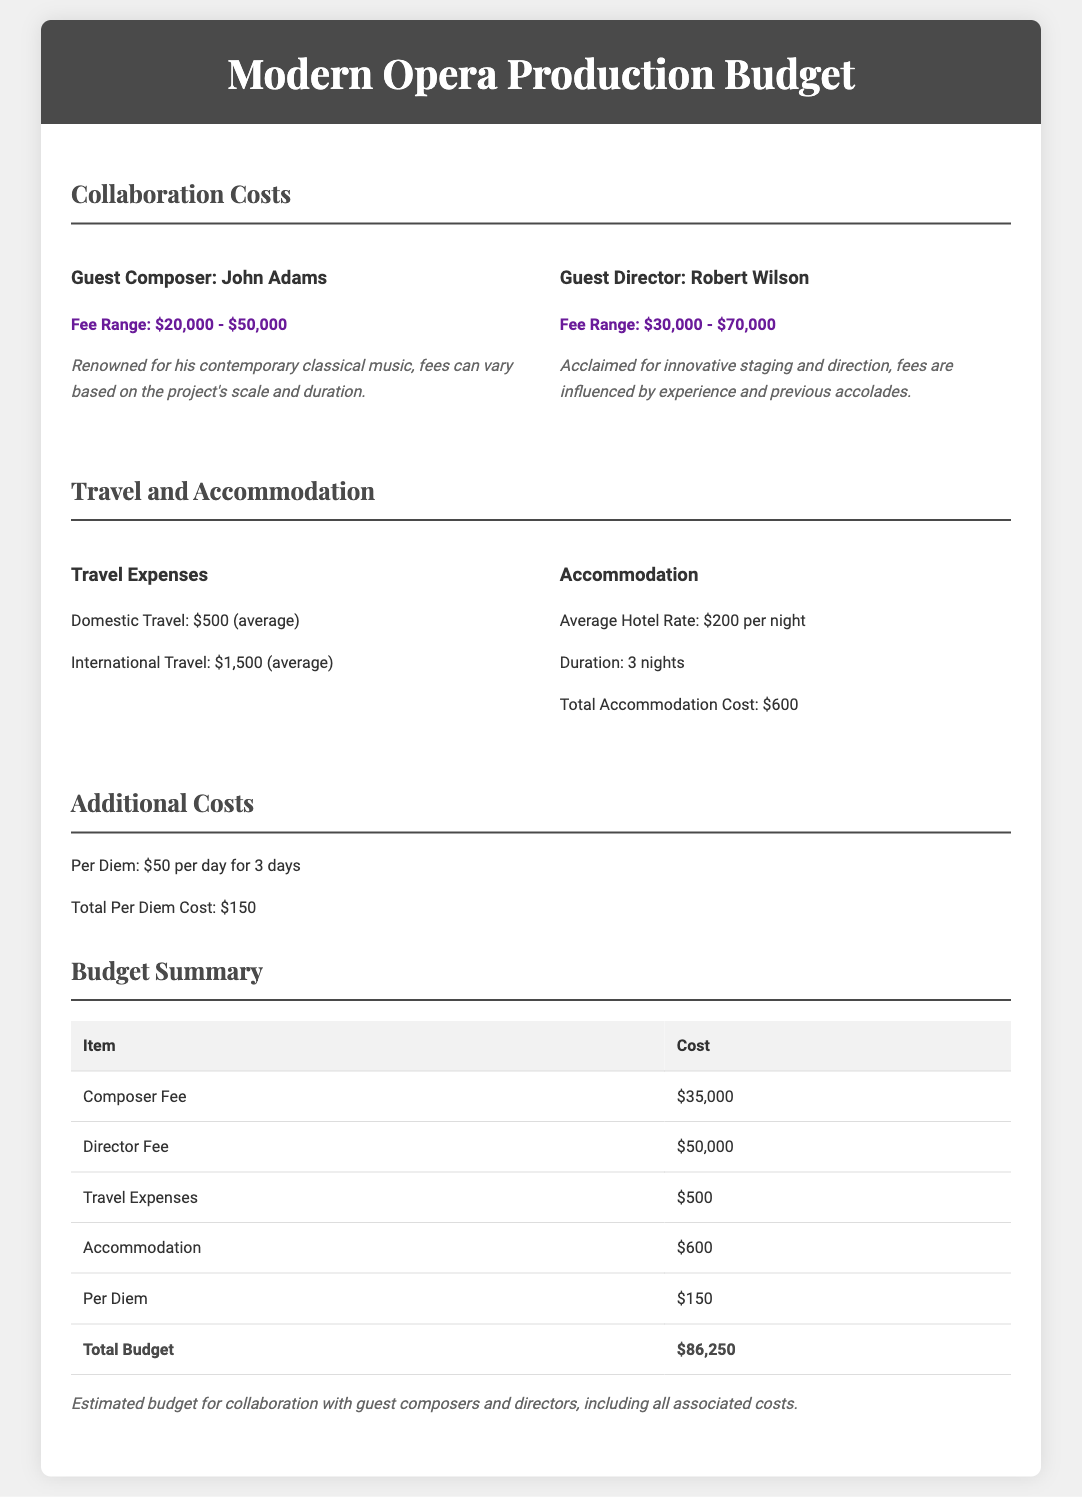What is the fee range for guest composer John Adams? The fee range for John Adams is detailed in the document as $20,000 - $50,000.
Answer: $20,000 - $50,000 What is the total accommodation cost? The total accommodation cost is mentioned in the document as $600, derived from the average hotel rate and duration.
Answer: $600 How much is the per diem cost for 3 days? The per diem cost is specified as $50 per day for 3 days, totaling $150.
Answer: $150 What is the travel expense for domestic travel? The document states that domestic travel expenses average around $500.
Answer: $500 What is the total budget for collaboration costs? The total budget sums all costs and is clearly listed as $86,250 in the budget summary.
Answer: $86,250 What is the fee range for guest director Robert Wilson? The fee range for Robert Wilson is written as $30,000 - $70,000 in the document.
Answer: $30,000 - $70,000 How many nights is the accommodation planned for? The document specifies that the accommodation duration is for 3 nights.
Answer: 3 nights What is the cost for international travel? The international travel cost is mentioned as averaging $1,500 in the document.
Answer: $1,500 What is the average hotel rate per night? According to the document, the average hotel rate is stated as $200 per night.
Answer: $200 